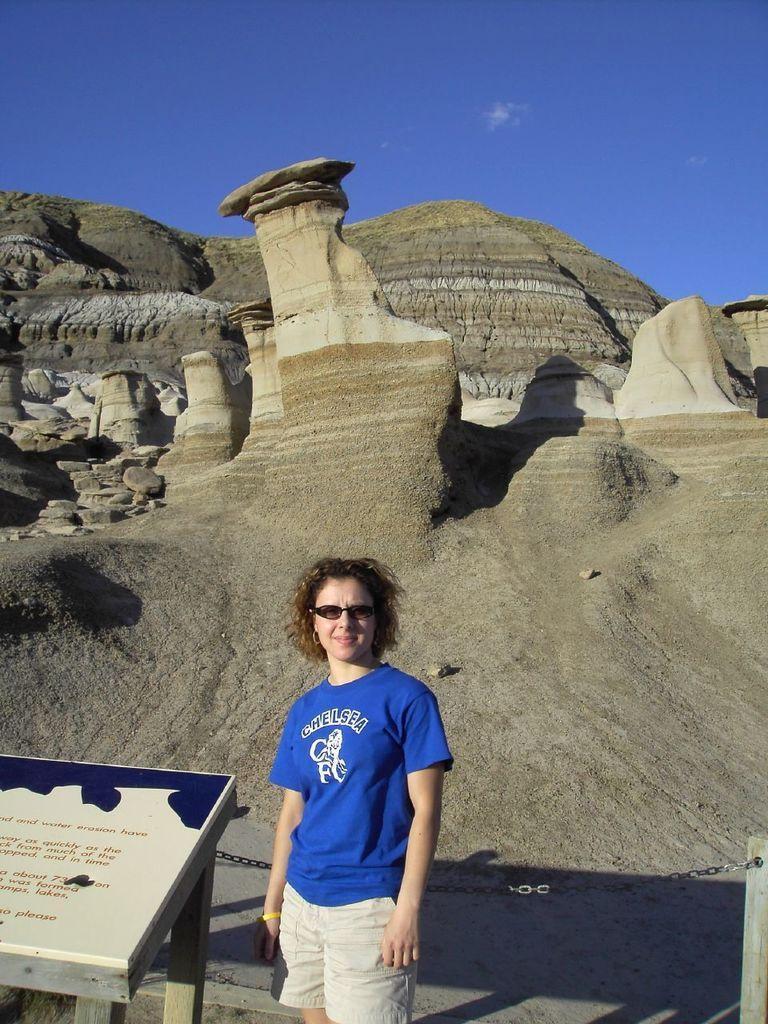Who is present in the image? There is a lady in the image. What is the lady wearing on her face? The lady is wearing goggles. What can be seen near the lady? There is a stand with a board near the lady. What is written on the board? There is text on the board. What can be seen in the distance in the image? There are rocks in the background of the image. What is visible in the sky in the image? The sky is visible in the background of the image, and there are clouds in the sky. What type of paint is being used during the operation in the image? There is no paint or operation present in the image. 